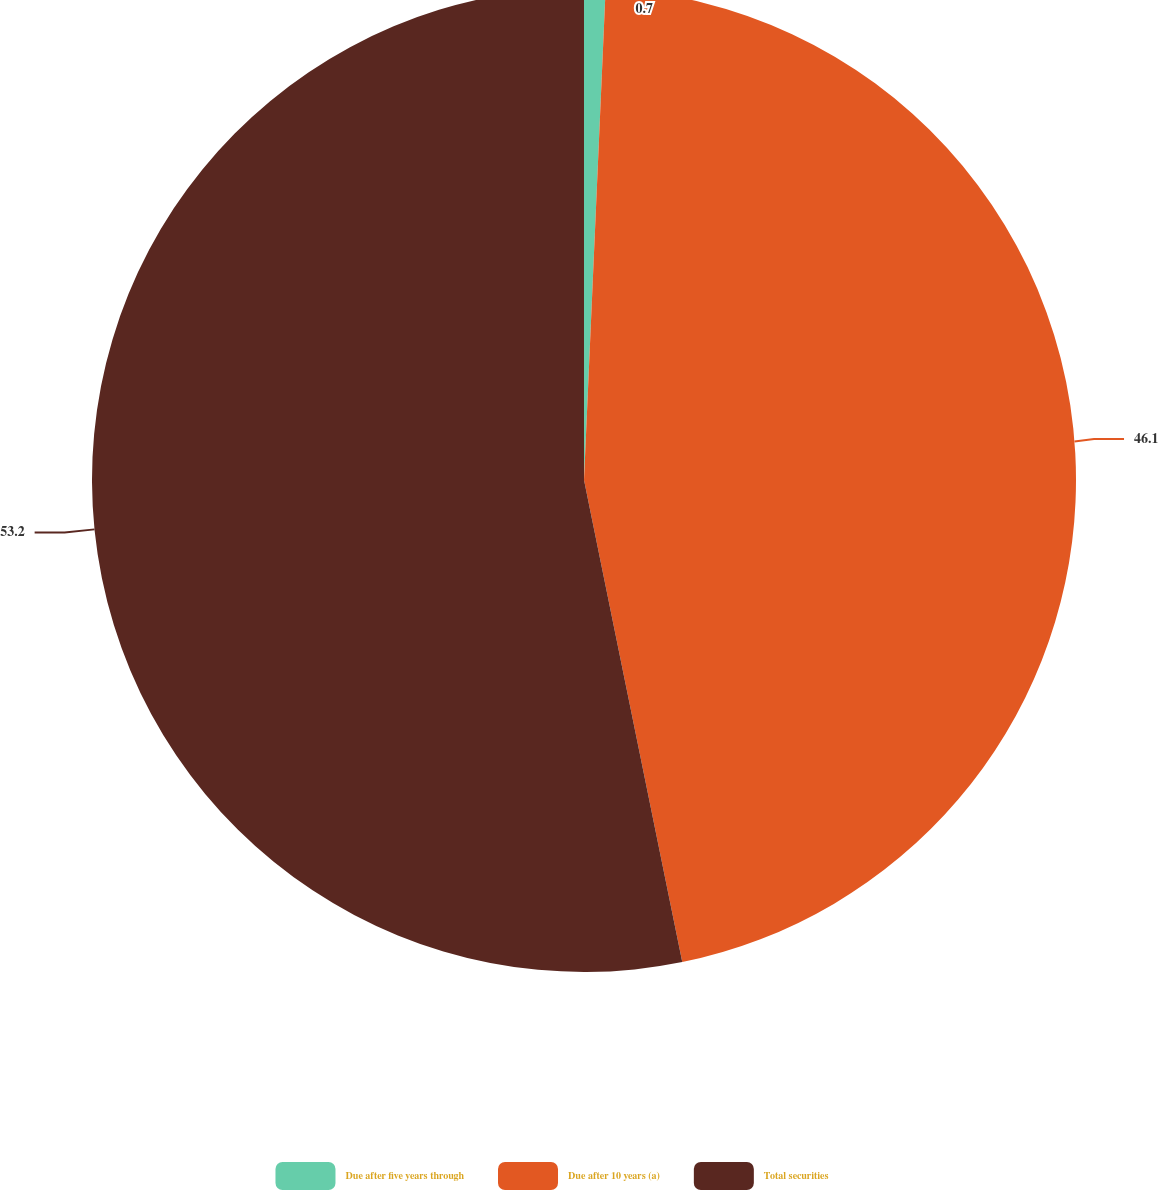Convert chart to OTSL. <chart><loc_0><loc_0><loc_500><loc_500><pie_chart><fcel>Due after five years through<fcel>Due after 10 years (a)<fcel>Total securities<nl><fcel>0.7%<fcel>46.1%<fcel>53.2%<nl></chart> 